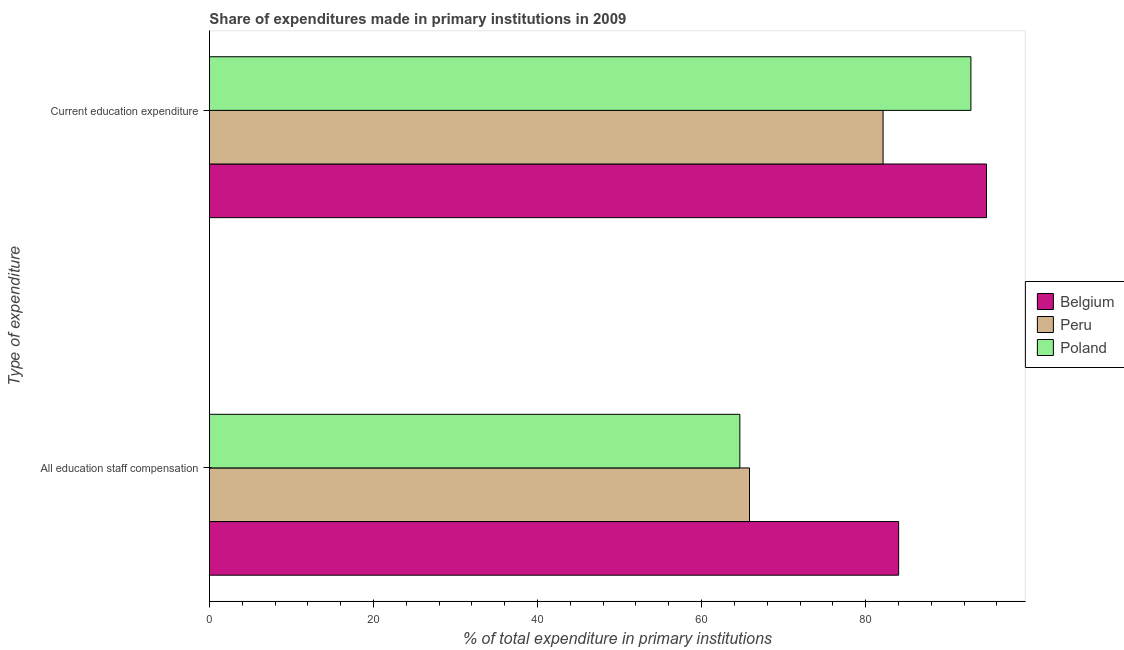How many different coloured bars are there?
Offer a terse response. 3. Are the number of bars per tick equal to the number of legend labels?
Keep it short and to the point. Yes. How many bars are there on the 2nd tick from the top?
Offer a very short reply. 3. What is the label of the 2nd group of bars from the top?
Offer a very short reply. All education staff compensation. What is the expenditure in education in Peru?
Your answer should be very brief. 82.13. Across all countries, what is the maximum expenditure in staff compensation?
Your answer should be compact. 84.03. Across all countries, what is the minimum expenditure in education?
Offer a terse response. 82.13. What is the total expenditure in staff compensation in the graph?
Your answer should be compact. 214.54. What is the difference between the expenditure in education in Peru and that in Poland?
Your response must be concise. -10.71. What is the difference between the expenditure in education in Peru and the expenditure in staff compensation in Belgium?
Keep it short and to the point. -1.9. What is the average expenditure in education per country?
Provide a short and direct response. 89.9. What is the difference between the expenditure in education and expenditure in staff compensation in Belgium?
Make the answer very short. 10.71. In how many countries, is the expenditure in education greater than 56 %?
Make the answer very short. 3. What is the ratio of the expenditure in staff compensation in Peru to that in Poland?
Keep it short and to the point. 1.02. In how many countries, is the expenditure in staff compensation greater than the average expenditure in staff compensation taken over all countries?
Make the answer very short. 1. What does the 3rd bar from the top in All education staff compensation represents?
Provide a succinct answer. Belgium. What does the 3rd bar from the bottom in Current education expenditure represents?
Offer a very short reply. Poland. What is the difference between two consecutive major ticks on the X-axis?
Offer a terse response. 20. Are the values on the major ticks of X-axis written in scientific E-notation?
Provide a succinct answer. No. Does the graph contain any zero values?
Your answer should be compact. No. Does the graph contain grids?
Provide a succinct answer. No. How are the legend labels stacked?
Your answer should be compact. Vertical. What is the title of the graph?
Ensure brevity in your answer.  Share of expenditures made in primary institutions in 2009. What is the label or title of the X-axis?
Make the answer very short. % of total expenditure in primary institutions. What is the label or title of the Y-axis?
Your response must be concise. Type of expenditure. What is the % of total expenditure in primary institutions of Belgium in All education staff compensation?
Ensure brevity in your answer.  84.03. What is the % of total expenditure in primary institutions in Peru in All education staff compensation?
Make the answer very short. 65.84. What is the % of total expenditure in primary institutions in Poland in All education staff compensation?
Your response must be concise. 64.67. What is the % of total expenditure in primary institutions in Belgium in Current education expenditure?
Your response must be concise. 94.74. What is the % of total expenditure in primary institutions of Peru in Current education expenditure?
Keep it short and to the point. 82.13. What is the % of total expenditure in primary institutions in Poland in Current education expenditure?
Make the answer very short. 92.84. Across all Type of expenditure, what is the maximum % of total expenditure in primary institutions of Belgium?
Your answer should be very brief. 94.74. Across all Type of expenditure, what is the maximum % of total expenditure in primary institutions of Peru?
Keep it short and to the point. 82.13. Across all Type of expenditure, what is the maximum % of total expenditure in primary institutions of Poland?
Offer a very short reply. 92.84. Across all Type of expenditure, what is the minimum % of total expenditure in primary institutions of Belgium?
Provide a short and direct response. 84.03. Across all Type of expenditure, what is the minimum % of total expenditure in primary institutions in Peru?
Make the answer very short. 65.84. Across all Type of expenditure, what is the minimum % of total expenditure in primary institutions in Poland?
Your response must be concise. 64.67. What is the total % of total expenditure in primary institutions of Belgium in the graph?
Your response must be concise. 178.76. What is the total % of total expenditure in primary institutions of Peru in the graph?
Offer a very short reply. 147.97. What is the total % of total expenditure in primary institutions of Poland in the graph?
Provide a succinct answer. 157.5. What is the difference between the % of total expenditure in primary institutions in Belgium in All education staff compensation and that in Current education expenditure?
Your answer should be compact. -10.71. What is the difference between the % of total expenditure in primary institutions in Peru in All education staff compensation and that in Current education expenditure?
Your answer should be compact. -16.28. What is the difference between the % of total expenditure in primary institutions in Poland in All education staff compensation and that in Current education expenditure?
Provide a succinct answer. -28.17. What is the difference between the % of total expenditure in primary institutions of Belgium in All education staff compensation and the % of total expenditure in primary institutions of Peru in Current education expenditure?
Provide a succinct answer. 1.9. What is the difference between the % of total expenditure in primary institutions of Belgium in All education staff compensation and the % of total expenditure in primary institutions of Poland in Current education expenditure?
Offer a very short reply. -8.81. What is the difference between the % of total expenditure in primary institutions of Peru in All education staff compensation and the % of total expenditure in primary institutions of Poland in Current education expenditure?
Keep it short and to the point. -26.99. What is the average % of total expenditure in primary institutions in Belgium per Type of expenditure?
Ensure brevity in your answer.  89.38. What is the average % of total expenditure in primary institutions of Peru per Type of expenditure?
Provide a succinct answer. 73.99. What is the average % of total expenditure in primary institutions in Poland per Type of expenditure?
Provide a short and direct response. 78.75. What is the difference between the % of total expenditure in primary institutions of Belgium and % of total expenditure in primary institutions of Peru in All education staff compensation?
Your answer should be compact. 18.18. What is the difference between the % of total expenditure in primary institutions of Belgium and % of total expenditure in primary institutions of Poland in All education staff compensation?
Provide a short and direct response. 19.36. What is the difference between the % of total expenditure in primary institutions of Peru and % of total expenditure in primary institutions of Poland in All education staff compensation?
Your answer should be very brief. 1.18. What is the difference between the % of total expenditure in primary institutions in Belgium and % of total expenditure in primary institutions in Peru in Current education expenditure?
Offer a very short reply. 12.61. What is the difference between the % of total expenditure in primary institutions of Belgium and % of total expenditure in primary institutions of Poland in Current education expenditure?
Your answer should be compact. 1.9. What is the difference between the % of total expenditure in primary institutions of Peru and % of total expenditure in primary institutions of Poland in Current education expenditure?
Your response must be concise. -10.71. What is the ratio of the % of total expenditure in primary institutions in Belgium in All education staff compensation to that in Current education expenditure?
Provide a short and direct response. 0.89. What is the ratio of the % of total expenditure in primary institutions in Peru in All education staff compensation to that in Current education expenditure?
Your answer should be compact. 0.8. What is the ratio of the % of total expenditure in primary institutions in Poland in All education staff compensation to that in Current education expenditure?
Provide a short and direct response. 0.7. What is the difference between the highest and the second highest % of total expenditure in primary institutions in Belgium?
Make the answer very short. 10.71. What is the difference between the highest and the second highest % of total expenditure in primary institutions of Peru?
Offer a very short reply. 16.28. What is the difference between the highest and the second highest % of total expenditure in primary institutions in Poland?
Give a very brief answer. 28.17. What is the difference between the highest and the lowest % of total expenditure in primary institutions of Belgium?
Offer a terse response. 10.71. What is the difference between the highest and the lowest % of total expenditure in primary institutions in Peru?
Offer a very short reply. 16.28. What is the difference between the highest and the lowest % of total expenditure in primary institutions of Poland?
Keep it short and to the point. 28.17. 